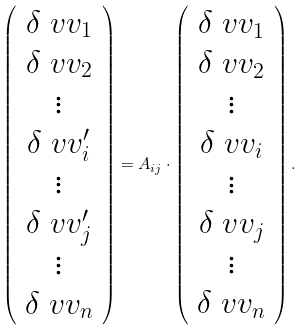Convert formula to latex. <formula><loc_0><loc_0><loc_500><loc_500>\left ( \begin{array} { c } \delta \ v v _ { 1 } \\ \delta \ v v _ { 2 } \\ \vdots \\ \delta \ v v _ { i } ^ { \prime } \\ \vdots \\ \delta \ v v _ { j } ^ { \prime } \\ \vdots \\ \delta \ v v _ { n } \end{array} \right ) = { A } _ { i j } \cdot \left ( \begin{array} { c } \delta \ v v _ { 1 } \\ \delta \ v v _ { 2 } \\ \vdots \\ \delta \ v v _ { i } \\ \vdots \\ \delta \ v v _ { j } \\ \vdots \\ \delta \ v v _ { n } \end{array} \right ) .</formula> 